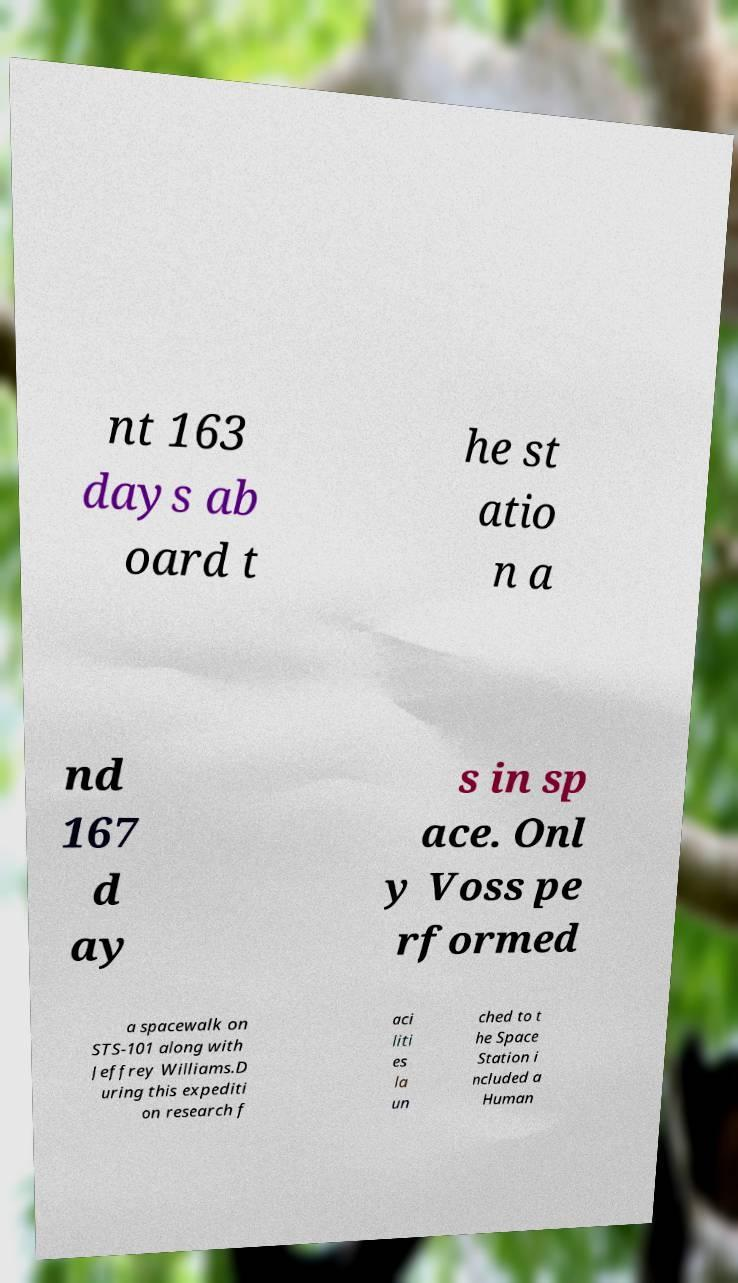Please read and relay the text visible in this image. What does it say? nt 163 days ab oard t he st atio n a nd 167 d ay s in sp ace. Onl y Voss pe rformed a spacewalk on STS-101 along with Jeffrey Williams.D uring this expediti on research f aci liti es la un ched to t he Space Station i ncluded a Human 